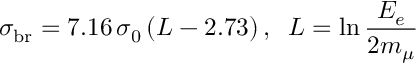<formula> <loc_0><loc_0><loc_500><loc_500>\sigma _ { b r } = 7 . 1 6 \, \sigma _ { 0 } \, ( L - 2 . 7 3 ) \, , \, L = \ln { \frac { E _ { e } } { 2 m _ { \mu } } }</formula> 